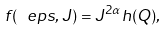<formula> <loc_0><loc_0><loc_500><loc_500>f ( \ e p s , J ) = J ^ { 2 \alpha } h ( Q ) ,</formula> 